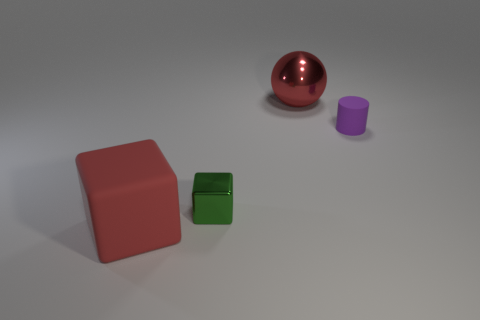Add 4 tiny brown cylinders. How many objects exist? 8 Subtract all spheres. How many objects are left? 3 Add 1 cubes. How many cubes are left? 3 Add 1 red rubber blocks. How many red rubber blocks exist? 2 Subtract 0 brown spheres. How many objects are left? 4 Subtract all tiny matte cylinders. Subtract all big red spheres. How many objects are left? 2 